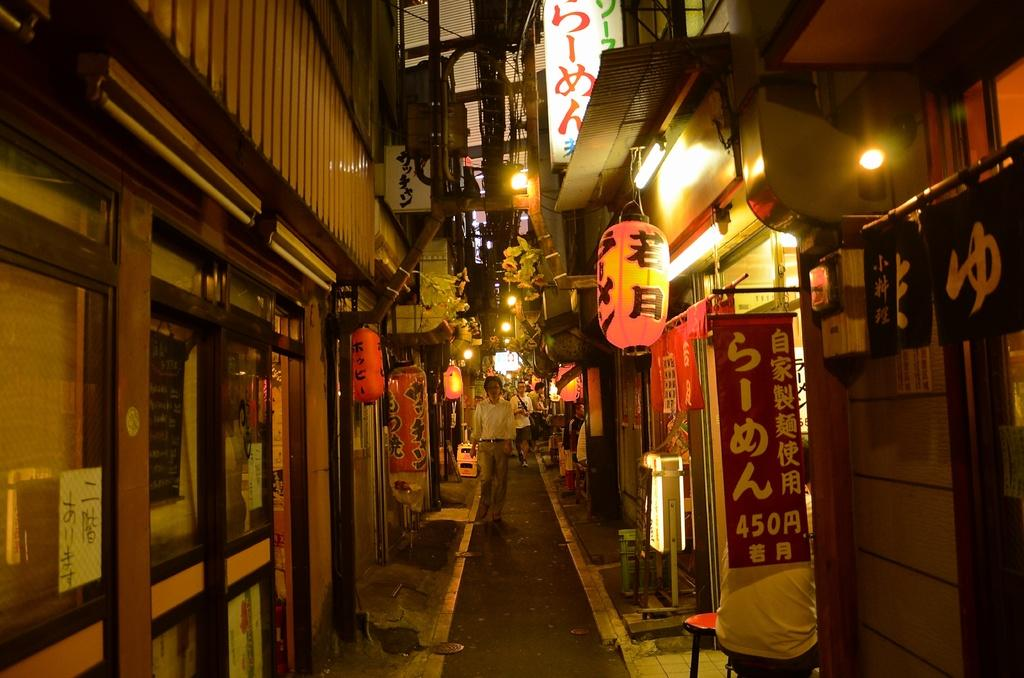What is the main setting of the image? There is a street in the image. What can be seen on the street? There are people standing on the street. What type of lighting is present in the image? There are lanterns and lights in the image. What structures are visible on both sides of the street? There are buildings on both sides of the street. What else is visible in the image? There are boards visible in the image. What type of leg is visible on the plate in the image? There is no plate or leg present in the image. What company is responsible for the lighting in the image? The image does not provide information about the company responsible for the lighting. 